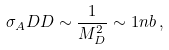Convert formula to latex. <formula><loc_0><loc_0><loc_500><loc_500>\sigma _ { A } D D \sim \frac { 1 } { M _ { D } ^ { 2 } } \sim 1 n b \, ,</formula> 